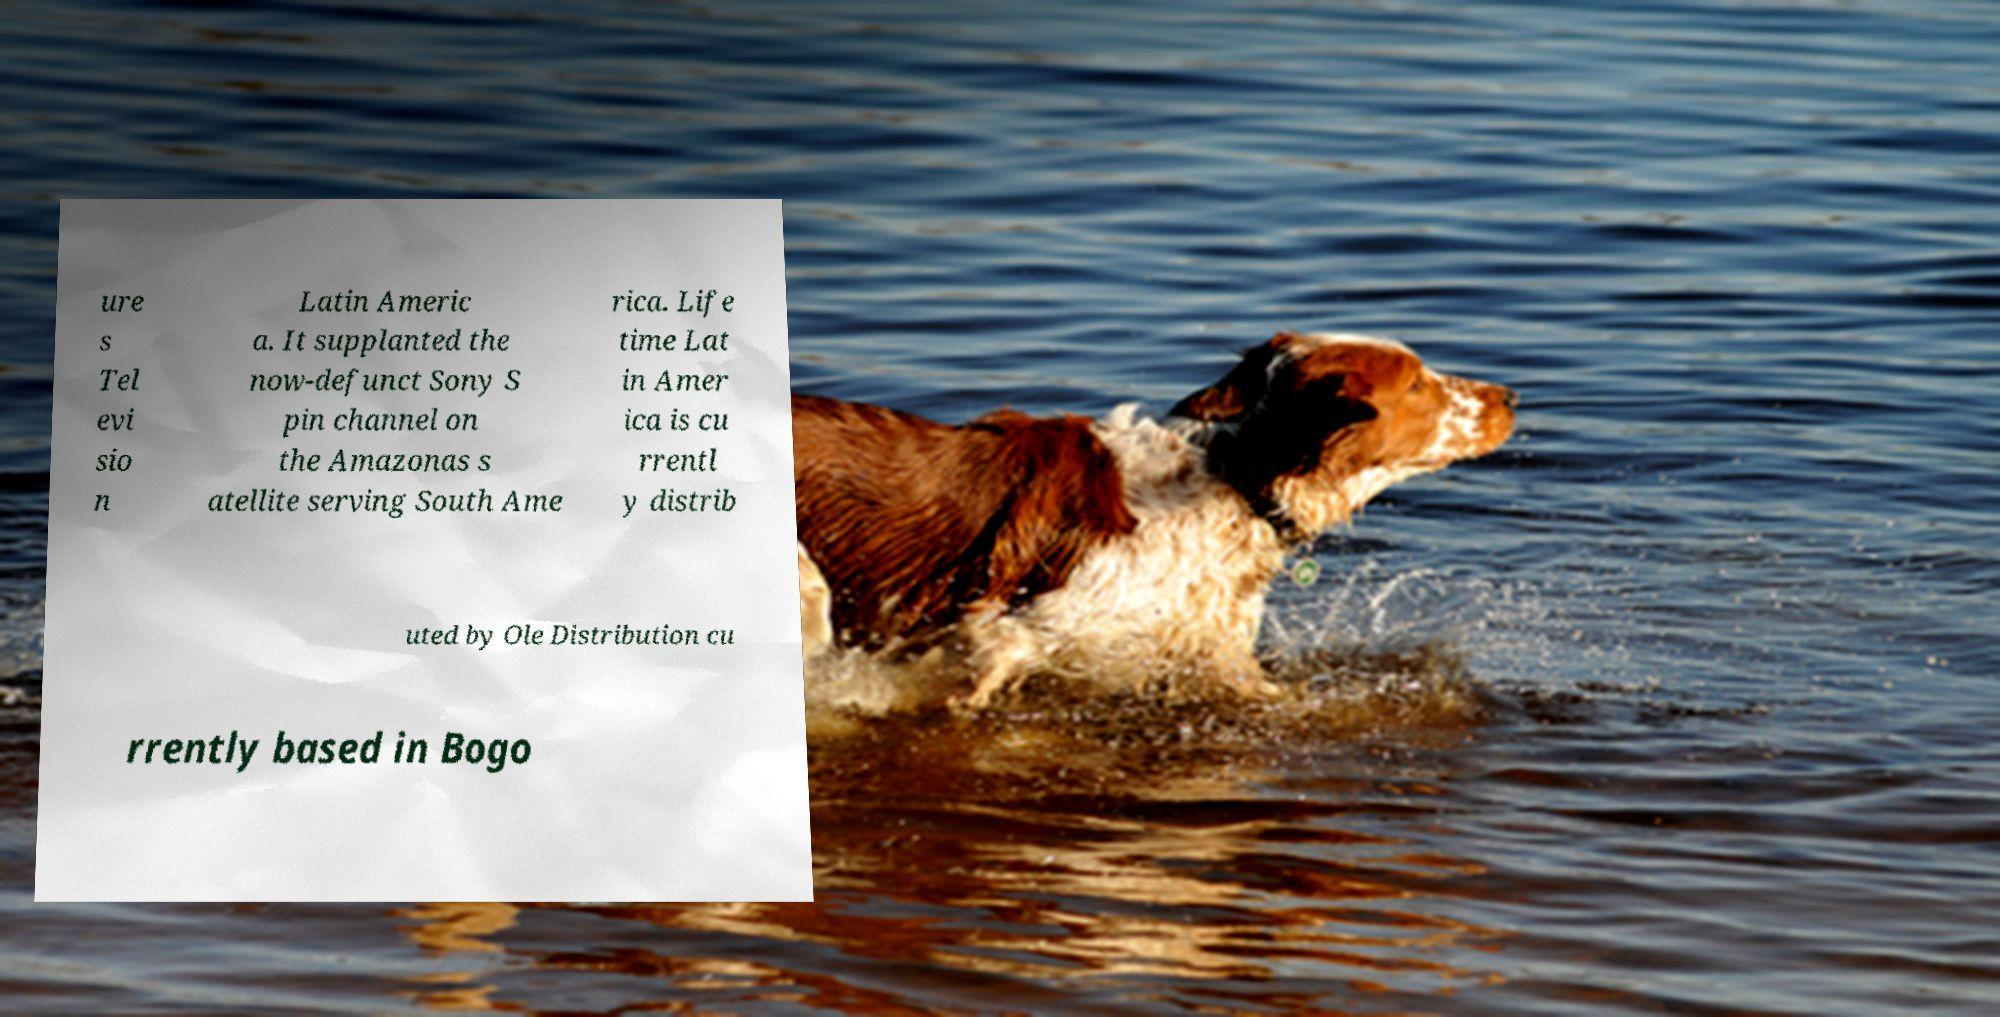Please read and relay the text visible in this image. What does it say? ure s Tel evi sio n Latin Americ a. It supplanted the now-defunct Sony S pin channel on the Amazonas s atellite serving South Ame rica. Life time Lat in Amer ica is cu rrentl y distrib uted by Ole Distribution cu rrently based in Bogo 